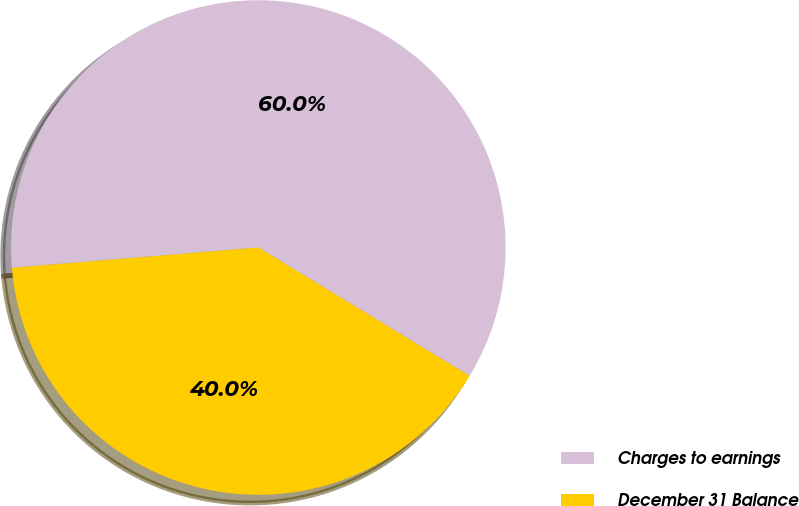<chart> <loc_0><loc_0><loc_500><loc_500><pie_chart><fcel>Charges to earnings<fcel>December 31 Balance<nl><fcel>60.0%<fcel>40.0%<nl></chart> 